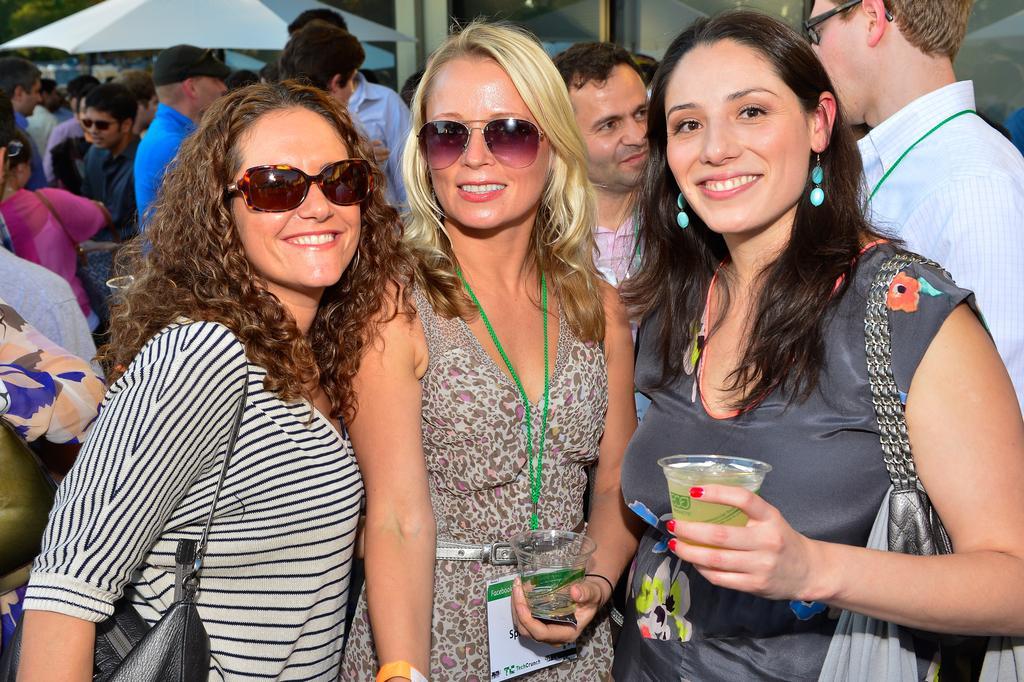In one or two sentences, can you explain what this image depicts? In this picture we can see there are three people standing and two women are holding the cups and smiling. Behind the people there are groups of people, umbrella and other things. 